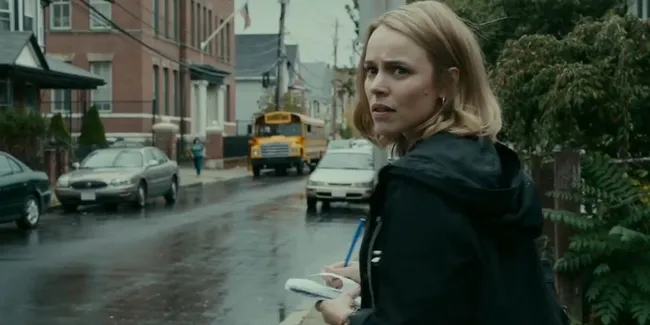Could you create a narrative based on this image? On a rainy afternoon, Anna found herself walking briskly down her neighborhood street, clutching her phone tightly. The wet pavement reflected the somber sky, and the occasional roar of passing cars broke through the patter of raindrops. She paused, turning back to glance anxiously over her shoulder, her heart pounding. Her eyes locked onto the familiar yellow school bus, now stationary, its significance weighing heavily on her mind. She couldn’t shake the feeling that something was amiss. The red-brick buildings loomed on either side, like silent sentinels witnessing her every move. With a deep breath, she steeled herself for what was to come, knowing that this was no ordinary day. Why do you think she looks concerned? Her concerned expression suggests that she might be waiting for an important phone call or has just received unsettling news. The urgency in her posture and the setting’s ambiance imply that something critical is unfolding. She could be worried about a loved one, reacting to a recent threat, or trying to make a crucial decision. The rainy, urban backdrop adds to the tension, creating a scene where immediate action or revelation is anticipated. What if the woman is not actually concerned but is planning something important? How would that change the context of the image? If the woman is not concerned but instead planning something important, the image takes on a different tone. Her focused expression could indicate deep concentration or anticipation. The phone in her hand might be a tool for executing her plan, perhaps coordinating a meetup or carrying out a strategic move. The urban setting with the school bus and red-brick buildings could then serve as a backdrop for her determined efforts, illuminating her proactive engagement rather than reaction to a tense moment. This reinterpretation shifts the narrative from one of passive concern to active agency. 